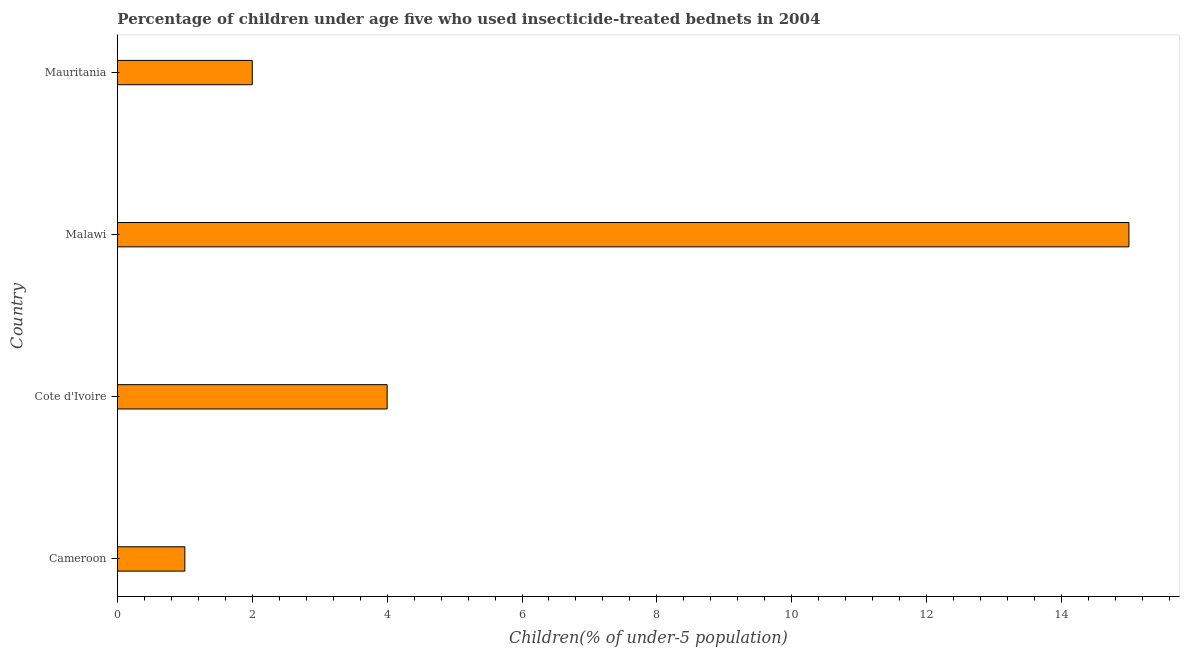What is the title of the graph?
Make the answer very short. Percentage of children under age five who used insecticide-treated bednets in 2004. What is the label or title of the X-axis?
Provide a succinct answer. Children(% of under-5 population). What is the percentage of children who use of insecticide-treated bed nets in Cameroon?
Your response must be concise. 1. Across all countries, what is the maximum percentage of children who use of insecticide-treated bed nets?
Make the answer very short. 15. In which country was the percentage of children who use of insecticide-treated bed nets maximum?
Give a very brief answer. Malawi. In which country was the percentage of children who use of insecticide-treated bed nets minimum?
Your response must be concise. Cameroon. What is the sum of the percentage of children who use of insecticide-treated bed nets?
Provide a succinct answer. 22. What is the difference between the percentage of children who use of insecticide-treated bed nets in Malawi and Mauritania?
Provide a succinct answer. 13. What is the average percentage of children who use of insecticide-treated bed nets per country?
Offer a very short reply. 5. In how many countries, is the percentage of children who use of insecticide-treated bed nets greater than 2 %?
Offer a very short reply. 2. What is the ratio of the percentage of children who use of insecticide-treated bed nets in Cameroon to that in Malawi?
Keep it short and to the point. 0.07. Is the difference between the percentage of children who use of insecticide-treated bed nets in Malawi and Mauritania greater than the difference between any two countries?
Give a very brief answer. No. What is the difference between the highest and the lowest percentage of children who use of insecticide-treated bed nets?
Keep it short and to the point. 14. How many bars are there?
Offer a very short reply. 4. How many countries are there in the graph?
Provide a short and direct response. 4. What is the difference between two consecutive major ticks on the X-axis?
Provide a short and direct response. 2. What is the Children(% of under-5 population) in Malawi?
Give a very brief answer. 15. What is the difference between the Children(% of under-5 population) in Cameroon and Cote d'Ivoire?
Offer a terse response. -3. What is the difference between the Children(% of under-5 population) in Cameroon and Malawi?
Provide a short and direct response. -14. What is the difference between the Children(% of under-5 population) in Cameroon and Mauritania?
Your answer should be very brief. -1. What is the difference between the Children(% of under-5 population) in Cote d'Ivoire and Mauritania?
Your answer should be very brief. 2. What is the difference between the Children(% of under-5 population) in Malawi and Mauritania?
Your answer should be very brief. 13. What is the ratio of the Children(% of under-5 population) in Cameroon to that in Malawi?
Your answer should be compact. 0.07. What is the ratio of the Children(% of under-5 population) in Cote d'Ivoire to that in Malawi?
Provide a short and direct response. 0.27. 